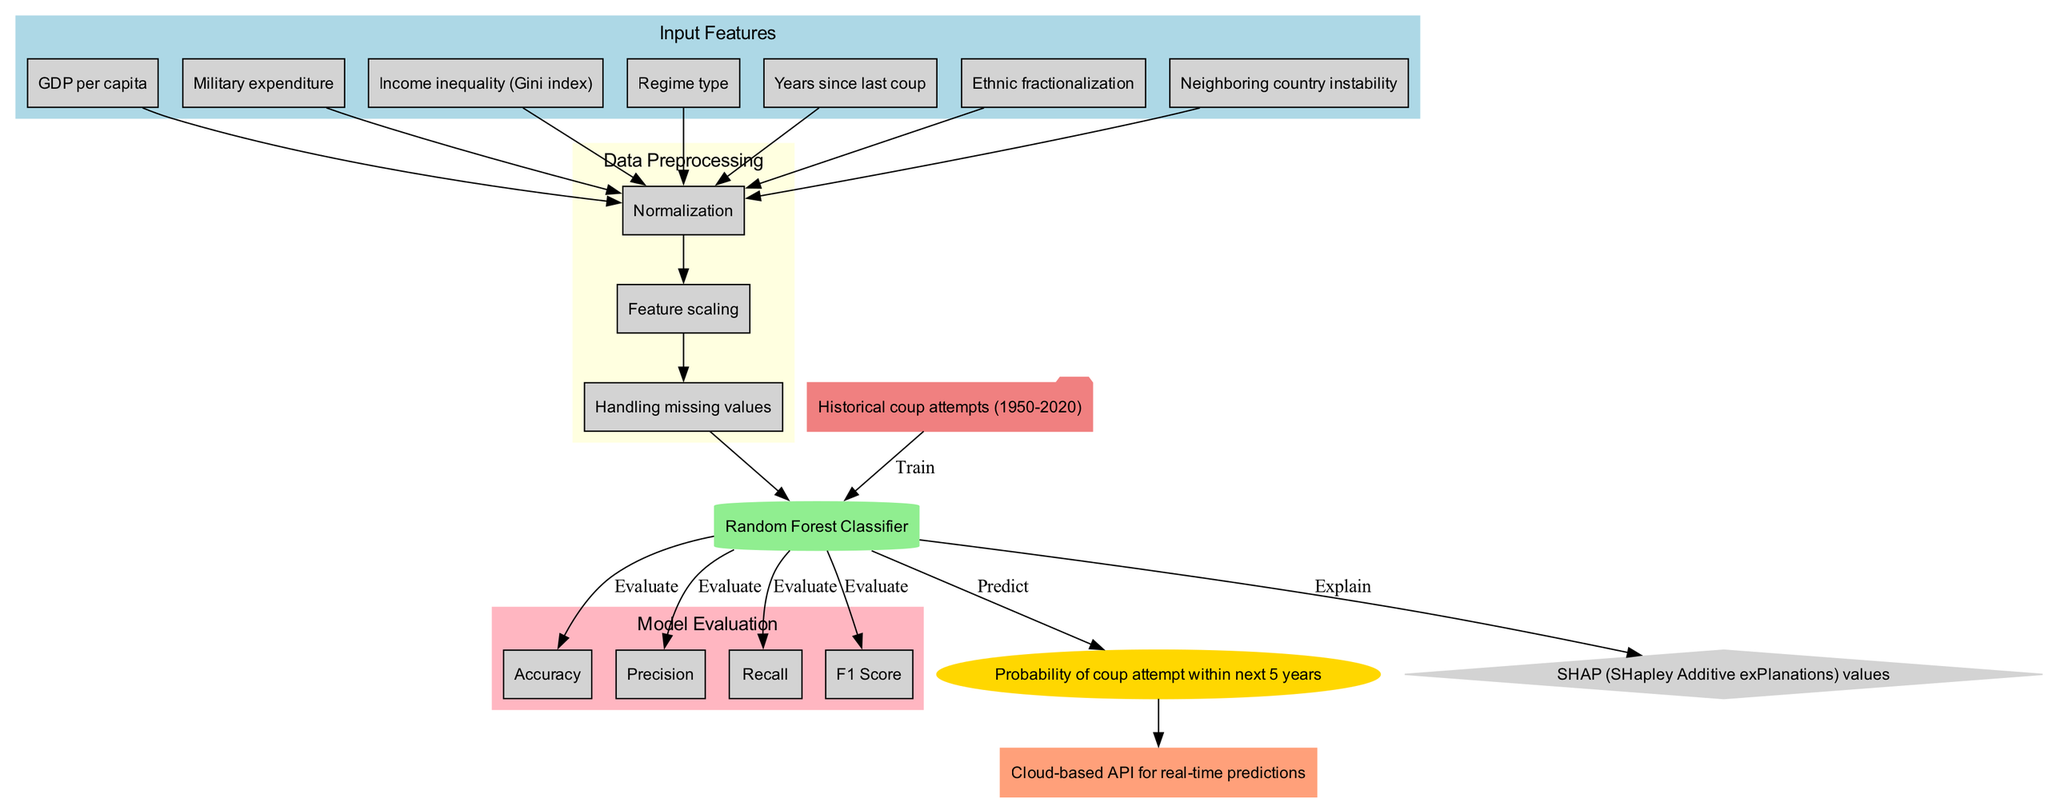What are the input features used in the model? The input features are listed in the diagram under the "Input Features" section. They include GDP per capita, Military expenditure, Income inequality (Gini index), Regime type, Years since last coup, Ethnic fractionalization, and Neighboring country instability.
Answer: GDP per capita, Military expenditure, Income inequality (Gini index), Regime type, Years since last coup, Ethnic fractionalization, Neighboring country instability How many preprocessing steps are there? The data preprocessing steps are shown in the "Data Preprocessing" section. There are three steps mentioned: Normalization, Feature scaling, and Handling missing values.
Answer: 3 What model architecture is used? The model architecture is indicated in the diagram as a single node labeled "Random Forest Classifier." This node is identified within the main flow after data preprocessing.
Answer: Random Forest Classifier What metrics are used for model evaluation? The metrics for model evaluation are displayed in the "Model Evaluation" section, which includes Accuracy, Precision, Recall, and F1 Score.
Answer: Accuracy, Precision, Recall, F1 Score Which step comes after handling missing values in preprocessing? After handling missing values, the next step listed in the diagram is "Feature scaling." This indicates the sequential flow from one preprocessing task to another.
Answer: Feature scaling What is the final output prediction of the model? The output prediction is shown in a distinct node labeled "Probability of coup attempt within next 5 years." This specifies what the model is predicting at the end of the process.
Answer: Probability of coup attempt within next 5 years Which method is used for model interpretability? The interpretability method identified in the diagram is SHAP (SHapley Additive exPlanations) values. This is indicated directly in the interpretability node linked to the model.
Answer: SHAP (SHapley Additive exPlanations) values Where is the model deployed? The deployment platform for the model is presented in a cloud-shaped node labeled "Cloud-based API for real-time predictions." This specifies the environment in which the model will operate post-training.
Answer: Cloud-based API for real-time predictions What is the relationship between training data and model architecture? The training data node connects to the model architecture node with an edge labeled "Train." This indicates that the training data is utilized to train the model architecture.
Answer: Train 